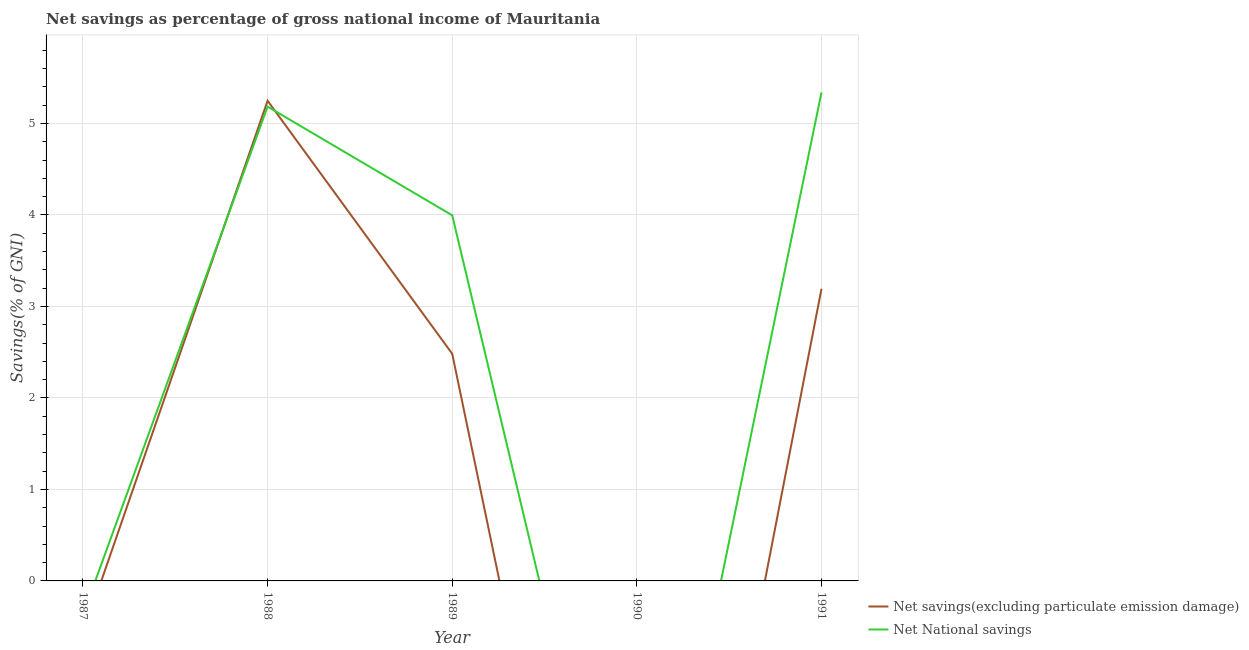How many different coloured lines are there?
Your answer should be very brief. 2. Does the line corresponding to net national savings intersect with the line corresponding to net savings(excluding particulate emission damage)?
Make the answer very short. Yes. What is the net national savings in 1991?
Ensure brevity in your answer.  5.34. Across all years, what is the maximum net savings(excluding particulate emission damage)?
Provide a succinct answer. 5.25. Across all years, what is the minimum net national savings?
Your response must be concise. 0. What is the total net savings(excluding particulate emission damage) in the graph?
Make the answer very short. 10.92. What is the difference between the net national savings in 1988 and that in 1989?
Ensure brevity in your answer.  1.19. What is the difference between the net savings(excluding particulate emission damage) in 1989 and the net national savings in 1990?
Provide a short and direct response. 2.48. What is the average net savings(excluding particulate emission damage) per year?
Your answer should be compact. 2.18. In the year 1988, what is the difference between the net national savings and net savings(excluding particulate emission damage)?
Provide a succinct answer. -0.06. In how many years, is the net national savings greater than 1.6 %?
Give a very brief answer. 3. What is the ratio of the net savings(excluding particulate emission damage) in 1989 to that in 1991?
Offer a terse response. 0.78. Is the difference between the net national savings in 1989 and 1991 greater than the difference between the net savings(excluding particulate emission damage) in 1989 and 1991?
Make the answer very short. No. What is the difference between the highest and the second highest net national savings?
Your answer should be very brief. 0.16. What is the difference between the highest and the lowest net savings(excluding particulate emission damage)?
Your answer should be very brief. 5.25. How many years are there in the graph?
Provide a succinct answer. 5. What is the difference between two consecutive major ticks on the Y-axis?
Your response must be concise. 1. Are the values on the major ticks of Y-axis written in scientific E-notation?
Ensure brevity in your answer.  No. How are the legend labels stacked?
Provide a short and direct response. Vertical. What is the title of the graph?
Offer a very short reply. Net savings as percentage of gross national income of Mauritania. What is the label or title of the X-axis?
Provide a short and direct response. Year. What is the label or title of the Y-axis?
Keep it short and to the point. Savings(% of GNI). What is the Savings(% of GNI) in Net savings(excluding particulate emission damage) in 1987?
Provide a short and direct response. 0. What is the Savings(% of GNI) in Net National savings in 1987?
Give a very brief answer. 0. What is the Savings(% of GNI) in Net savings(excluding particulate emission damage) in 1988?
Your answer should be compact. 5.25. What is the Savings(% of GNI) in Net National savings in 1988?
Provide a short and direct response. 5.18. What is the Savings(% of GNI) in Net savings(excluding particulate emission damage) in 1989?
Offer a terse response. 2.48. What is the Savings(% of GNI) in Net National savings in 1989?
Offer a very short reply. 4. What is the Savings(% of GNI) in Net National savings in 1990?
Your answer should be compact. 0. What is the Savings(% of GNI) of Net savings(excluding particulate emission damage) in 1991?
Ensure brevity in your answer.  3.19. What is the Savings(% of GNI) of Net National savings in 1991?
Offer a terse response. 5.34. Across all years, what is the maximum Savings(% of GNI) of Net savings(excluding particulate emission damage)?
Provide a succinct answer. 5.25. Across all years, what is the maximum Savings(% of GNI) of Net National savings?
Your response must be concise. 5.34. What is the total Savings(% of GNI) of Net savings(excluding particulate emission damage) in the graph?
Keep it short and to the point. 10.92. What is the total Savings(% of GNI) in Net National savings in the graph?
Offer a terse response. 14.52. What is the difference between the Savings(% of GNI) in Net savings(excluding particulate emission damage) in 1988 and that in 1989?
Offer a very short reply. 2.77. What is the difference between the Savings(% of GNI) of Net National savings in 1988 and that in 1989?
Offer a very short reply. 1.19. What is the difference between the Savings(% of GNI) in Net savings(excluding particulate emission damage) in 1988 and that in 1991?
Give a very brief answer. 2.05. What is the difference between the Savings(% of GNI) in Net National savings in 1988 and that in 1991?
Your answer should be compact. -0.16. What is the difference between the Savings(% of GNI) of Net savings(excluding particulate emission damage) in 1989 and that in 1991?
Keep it short and to the point. -0.71. What is the difference between the Savings(% of GNI) in Net National savings in 1989 and that in 1991?
Offer a terse response. -1.34. What is the difference between the Savings(% of GNI) in Net savings(excluding particulate emission damage) in 1988 and the Savings(% of GNI) in Net National savings in 1989?
Your answer should be very brief. 1.25. What is the difference between the Savings(% of GNI) of Net savings(excluding particulate emission damage) in 1988 and the Savings(% of GNI) of Net National savings in 1991?
Your response must be concise. -0.09. What is the difference between the Savings(% of GNI) of Net savings(excluding particulate emission damage) in 1989 and the Savings(% of GNI) of Net National savings in 1991?
Ensure brevity in your answer.  -2.86. What is the average Savings(% of GNI) in Net savings(excluding particulate emission damage) per year?
Your answer should be very brief. 2.18. What is the average Savings(% of GNI) of Net National savings per year?
Provide a succinct answer. 2.9. In the year 1988, what is the difference between the Savings(% of GNI) in Net savings(excluding particulate emission damage) and Savings(% of GNI) in Net National savings?
Offer a very short reply. 0.06. In the year 1989, what is the difference between the Savings(% of GNI) in Net savings(excluding particulate emission damage) and Savings(% of GNI) in Net National savings?
Make the answer very short. -1.51. In the year 1991, what is the difference between the Savings(% of GNI) in Net savings(excluding particulate emission damage) and Savings(% of GNI) in Net National savings?
Keep it short and to the point. -2.15. What is the ratio of the Savings(% of GNI) of Net savings(excluding particulate emission damage) in 1988 to that in 1989?
Your answer should be compact. 2.11. What is the ratio of the Savings(% of GNI) of Net National savings in 1988 to that in 1989?
Keep it short and to the point. 1.3. What is the ratio of the Savings(% of GNI) in Net savings(excluding particulate emission damage) in 1988 to that in 1991?
Provide a succinct answer. 1.64. What is the ratio of the Savings(% of GNI) of Net National savings in 1988 to that in 1991?
Keep it short and to the point. 0.97. What is the ratio of the Savings(% of GNI) in Net savings(excluding particulate emission damage) in 1989 to that in 1991?
Keep it short and to the point. 0.78. What is the ratio of the Savings(% of GNI) of Net National savings in 1989 to that in 1991?
Your response must be concise. 0.75. What is the difference between the highest and the second highest Savings(% of GNI) of Net savings(excluding particulate emission damage)?
Provide a short and direct response. 2.05. What is the difference between the highest and the second highest Savings(% of GNI) of Net National savings?
Offer a terse response. 0.16. What is the difference between the highest and the lowest Savings(% of GNI) in Net savings(excluding particulate emission damage)?
Your answer should be very brief. 5.25. What is the difference between the highest and the lowest Savings(% of GNI) of Net National savings?
Give a very brief answer. 5.34. 